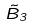Convert formula to latex. <formula><loc_0><loc_0><loc_500><loc_500>\tilde { B } _ { 3 }</formula> 